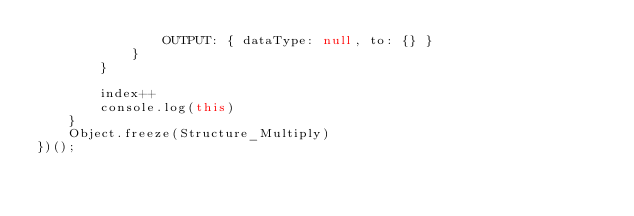Convert code to text. <code><loc_0><loc_0><loc_500><loc_500><_JavaScript_>                OUTPUT: { dataType: null, to: {} }
            }
        }
        
        index++
        console.log(this)
    }
    Object.freeze(Structure_Multiply)
})();</code> 